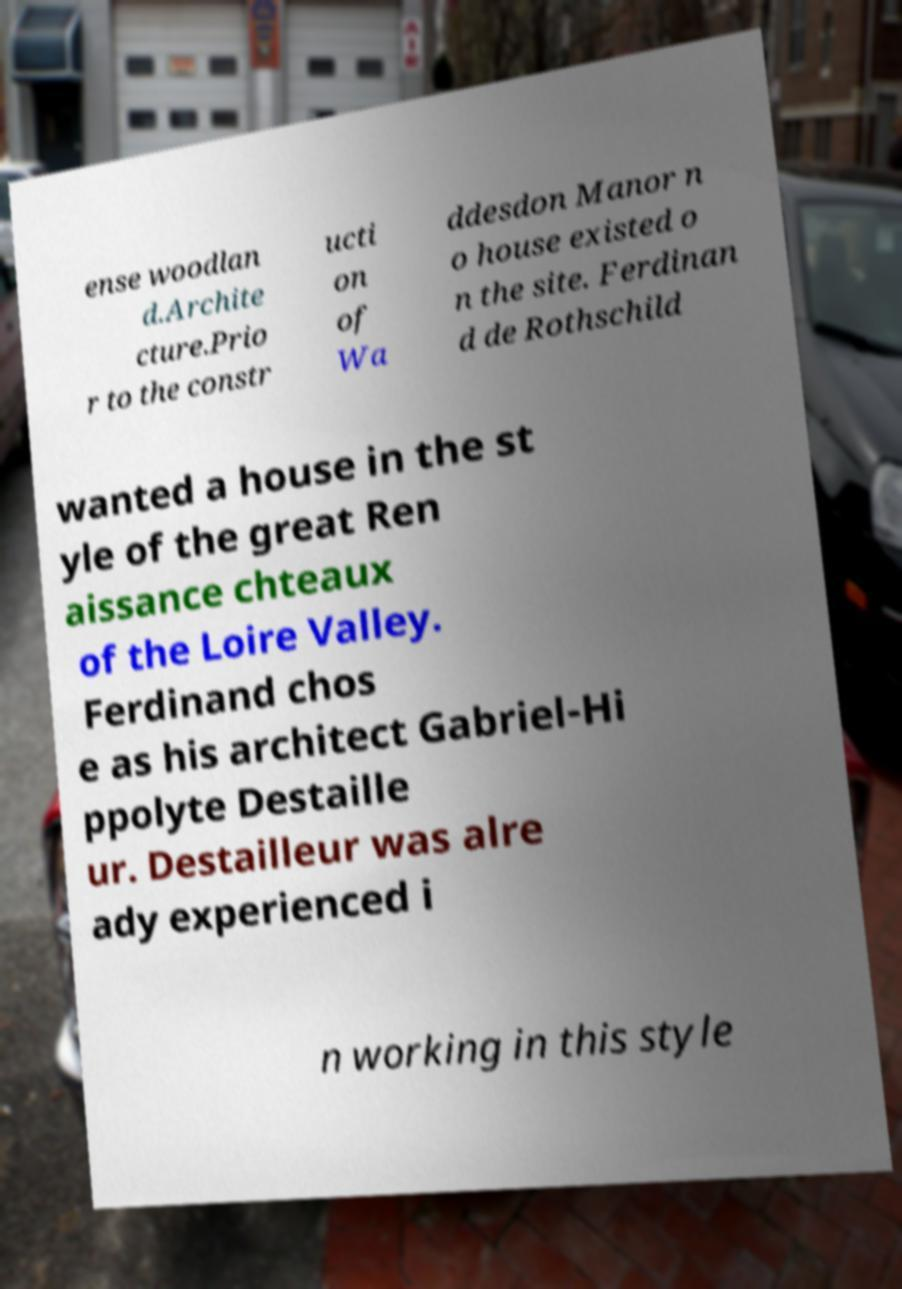What messages or text are displayed in this image? I need them in a readable, typed format. ense woodlan d.Archite cture.Prio r to the constr ucti on of Wa ddesdon Manor n o house existed o n the site. Ferdinan d de Rothschild wanted a house in the st yle of the great Ren aissance chteaux of the Loire Valley. Ferdinand chos e as his architect Gabriel-Hi ppolyte Destaille ur. Destailleur was alre ady experienced i n working in this style 